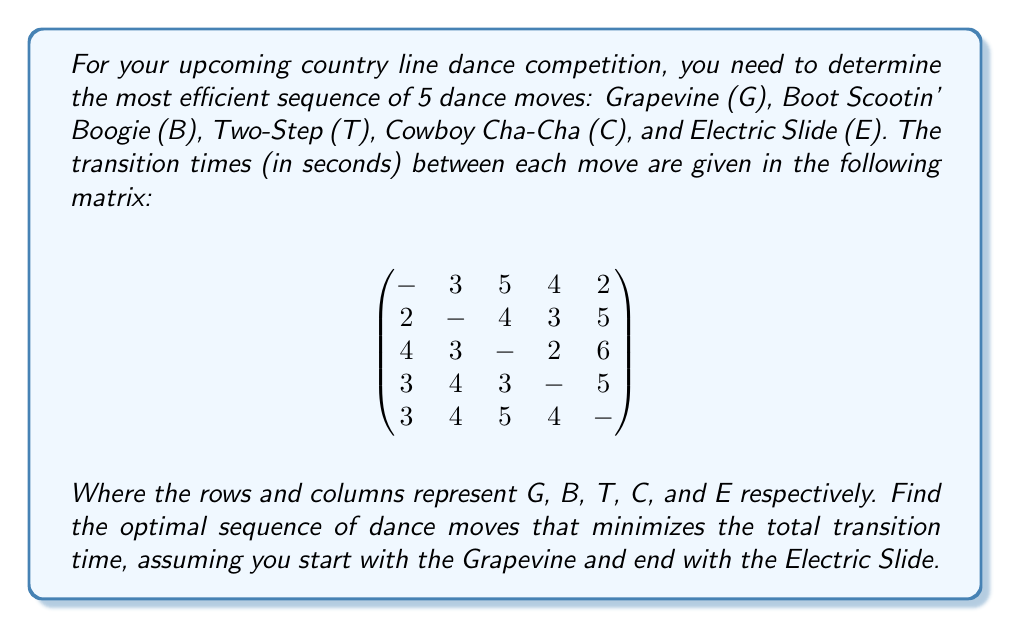What is the answer to this math problem? To solve this problem, we can use the concept of the Traveling Salesman Problem (TSP) with a fixed start and end point. Here's how to approach it:

1) First, note that we have a fixed start (Grapevine) and end (Electric Slide). This reduces our problem to finding the best order for the middle three moves.

2) We need to consider all possible permutations of the remaining three moves (B, T, C). There are 3! = 6 possible permutations.

3) For each permutation, we'll calculate the total transition time:
   - From G to the first move
   - Between the middle moves
   - From the last middle move to E

4) Let's calculate the time for each permutation:

   G-B-T-C-E: 3 + 4 + 3 + 5 = 15 seconds
   G-B-C-T-E: 3 + 3 + 2 + 5 = 13 seconds
   G-T-B-C-E: 5 + 3 + 3 + 5 = 16 seconds
   G-T-C-B-E: 5 + 2 + 4 + 5 = 16 seconds
   G-C-B-T-E: 4 + 4 + 4 + 5 = 17 seconds
   G-C-T-B-E: 4 + 3 + 3 + 5 = 15 seconds

5) The sequence with the minimum total transition time is G-B-C-T-E, with a total time of 13 seconds.
Answer: The optimal sequence of dance moves is: Grapevine (G) - Boot Scootin' Boogie (B) - Cowboy Cha-Cha (C) - Two-Step (T) - Electric Slide (E), with a total transition time of 13 seconds. 